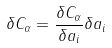<formula> <loc_0><loc_0><loc_500><loc_500>\delta C _ { \alpha } = \frac { \delta C _ { \alpha } } { \delta a _ { i } } \delta a _ { i }</formula> 